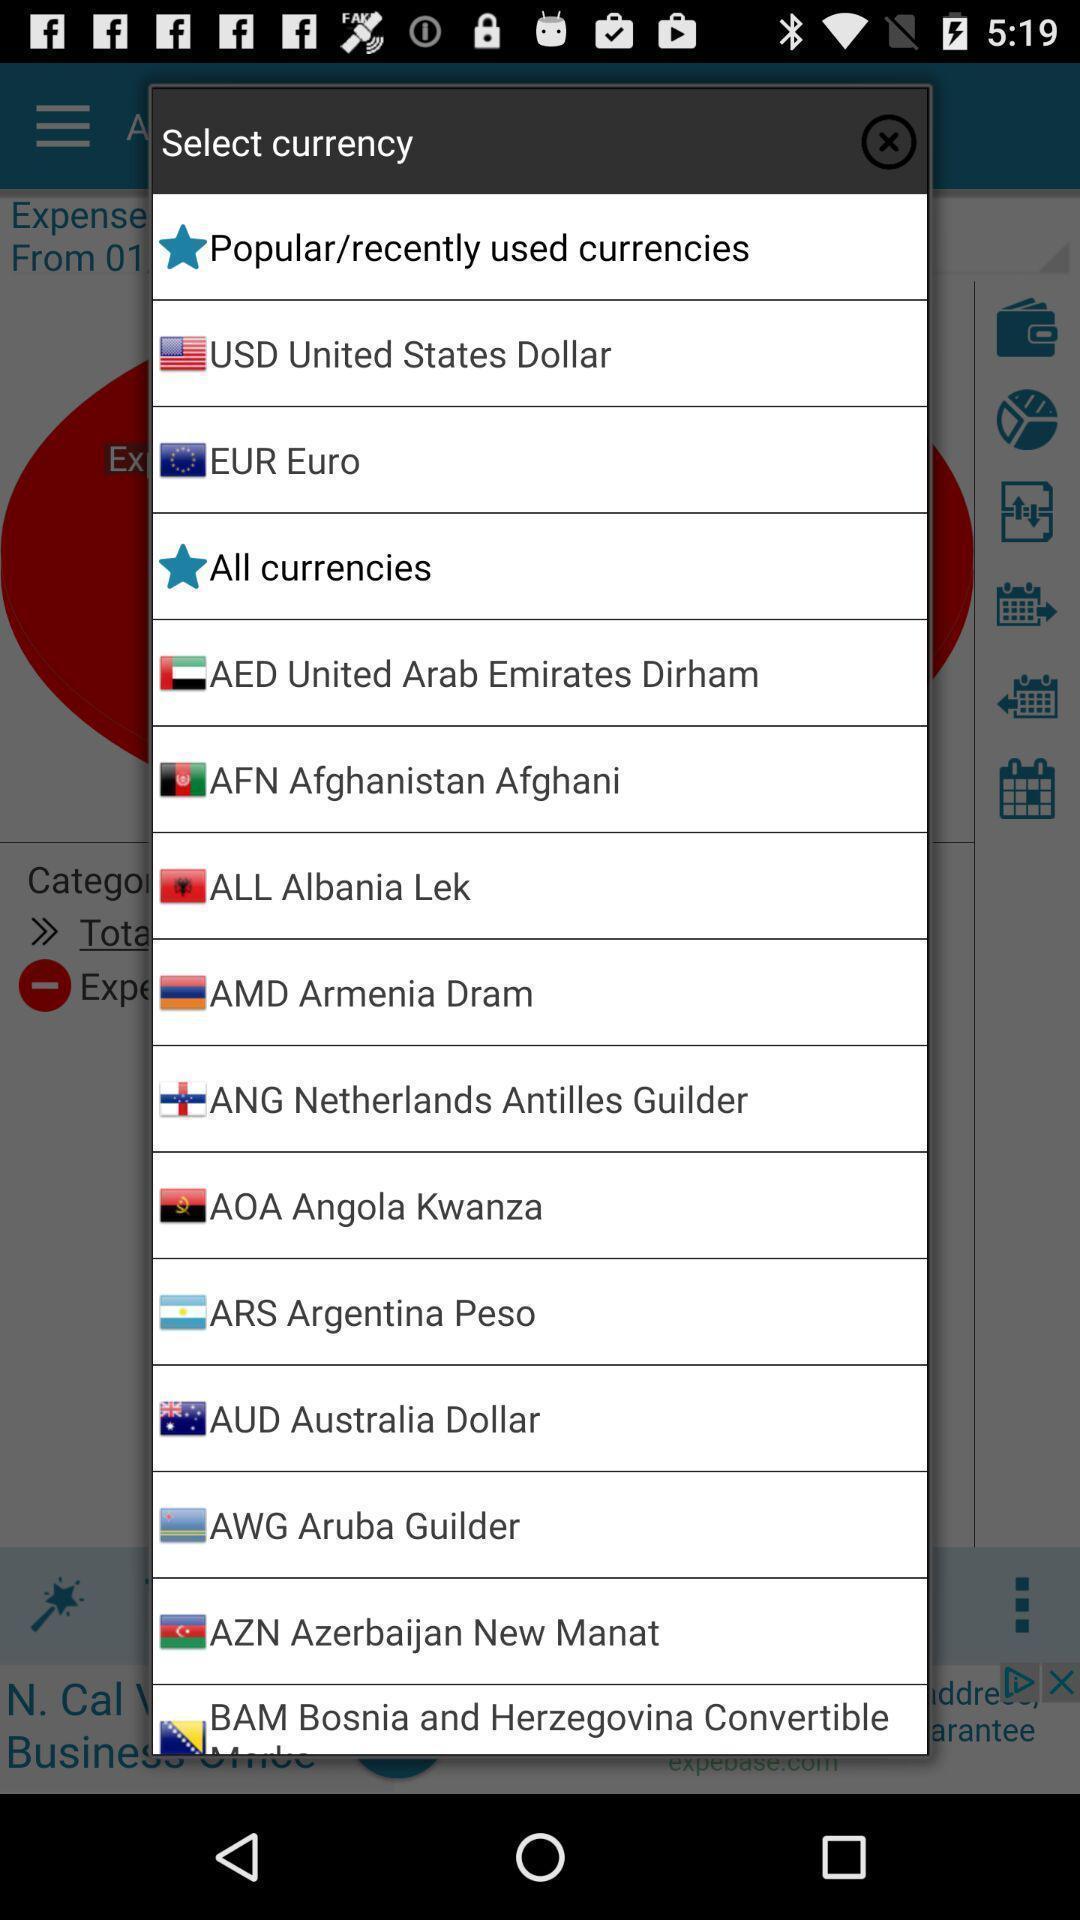Describe the content in this image. Popup to select the currency type in application. 